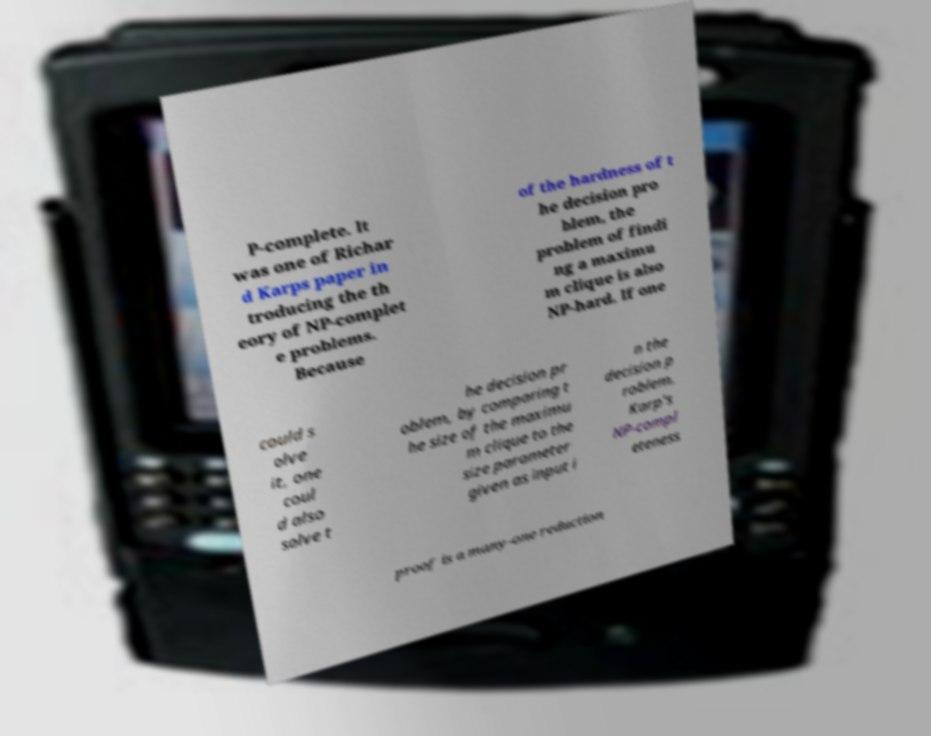Can you read and provide the text displayed in the image?This photo seems to have some interesting text. Can you extract and type it out for me? P-complete. It was one of Richar d Karps paper in troducing the th eory of NP-complet e problems. Because of the hardness of t he decision pro blem, the problem of findi ng a maximu m clique is also NP-hard. If one could s olve it, one coul d also solve t he decision pr oblem, by comparing t he size of the maximu m clique to the size parameter given as input i n the decision p roblem. Karp's NP-compl eteness proof is a many-one reduction 